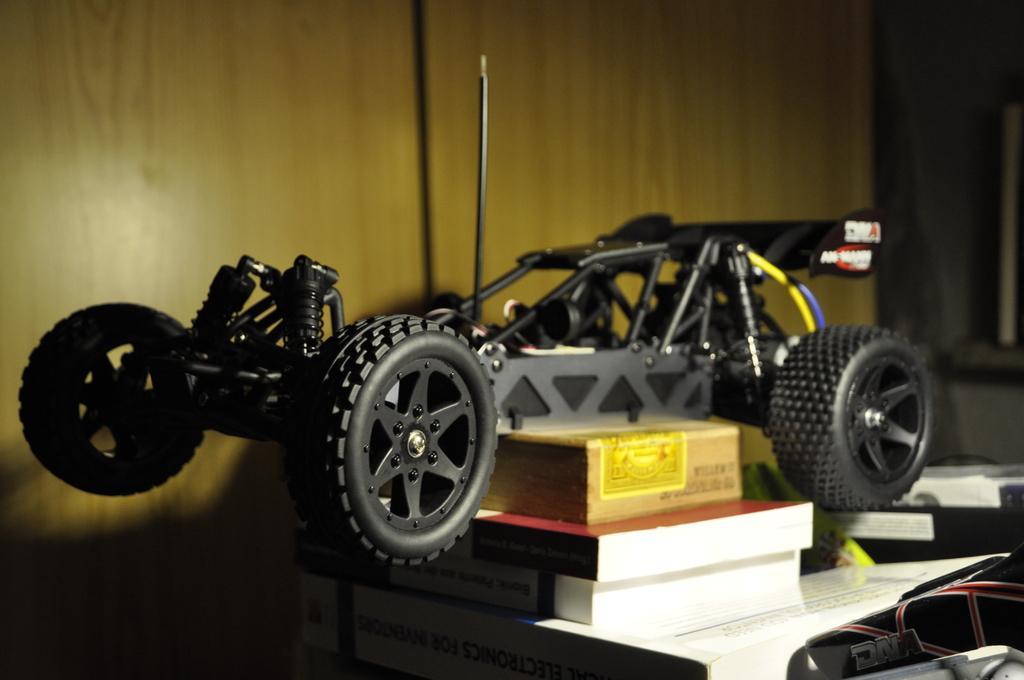Can you describe this image briefly? In this image there is a toy in middle of this image and there is wall in the background. there are some books kept at bottom of this image. 